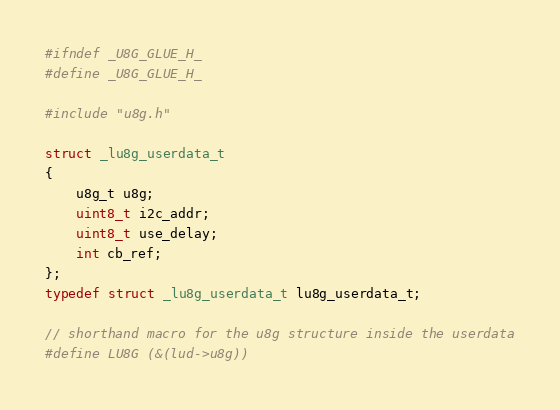Convert code to text. <code><loc_0><loc_0><loc_500><loc_500><_C_>
#ifndef _U8G_GLUE_H_
#define _U8G_GLUE_H_

#include "u8g.h"

struct _lu8g_userdata_t
{
    u8g_t u8g;
    uint8_t i2c_addr;
    uint8_t use_delay;
    int cb_ref;
};
typedef struct _lu8g_userdata_t lu8g_userdata_t;

// shorthand macro for the u8g structure inside the userdata
#define LU8G (&(lud->u8g))
</code> 